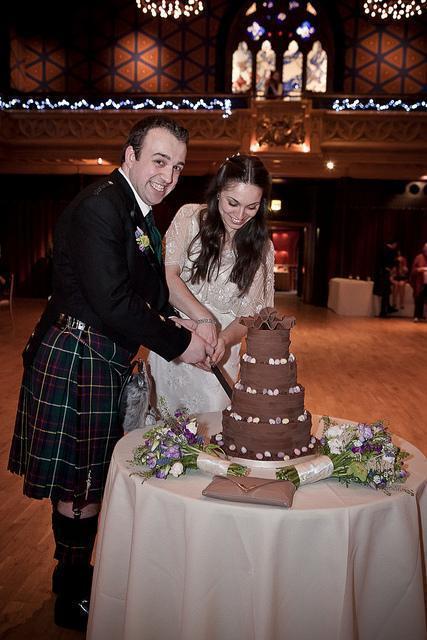How many people can be seen?
Give a very brief answer. 2. 